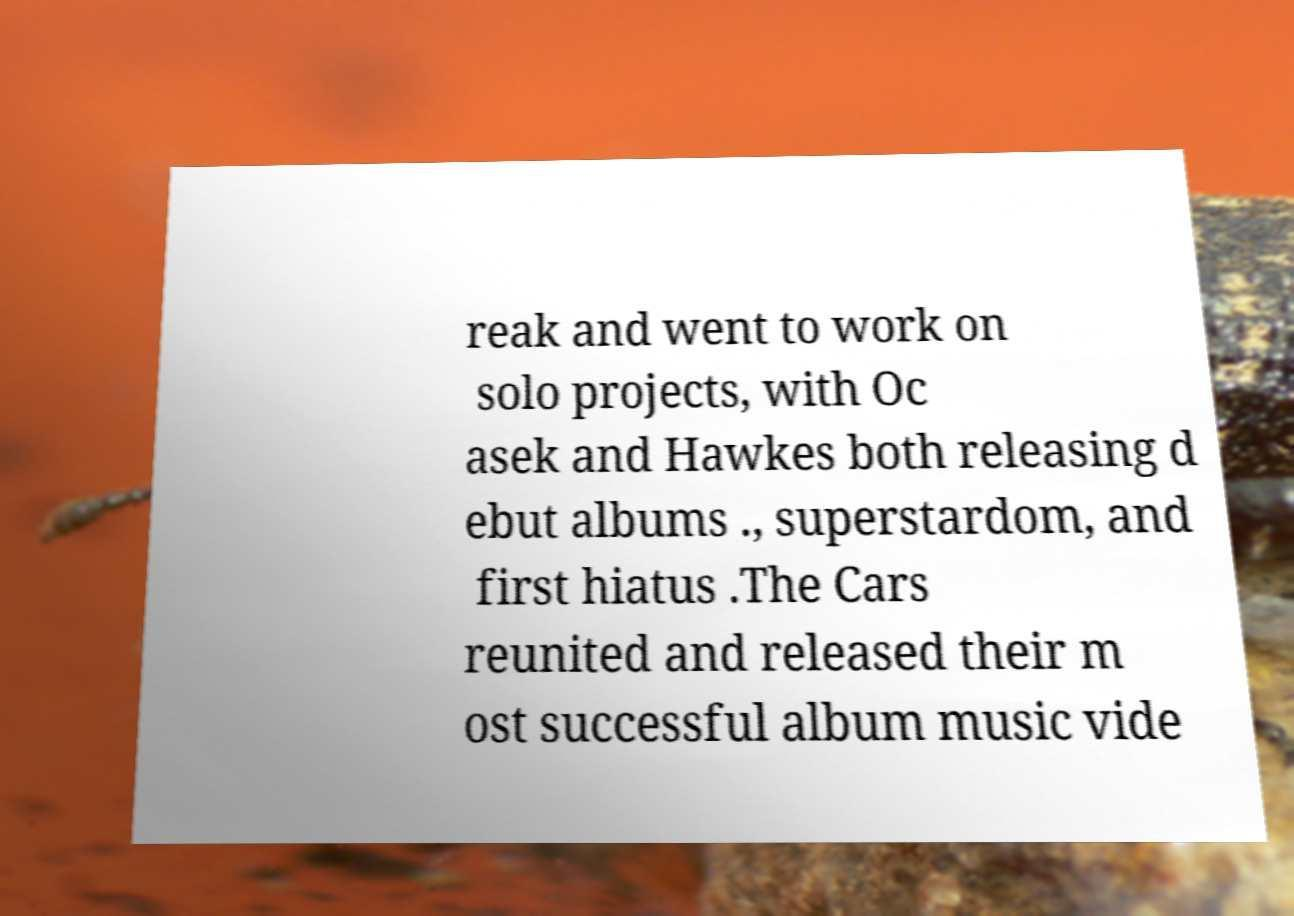Can you read and provide the text displayed in the image?This photo seems to have some interesting text. Can you extract and type it out for me? reak and went to work on solo projects, with Oc asek and Hawkes both releasing d ebut albums ., superstardom, and first hiatus .The Cars reunited and released their m ost successful album music vide 